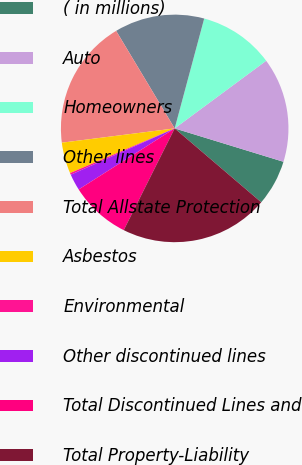<chart> <loc_0><loc_0><loc_500><loc_500><pie_chart><fcel>( in millions)<fcel>Auto<fcel>Homeowners<fcel>Other lines<fcel>Total Allstate Protection<fcel>Asbestos<fcel>Environmental<fcel>Other discontinued lines<fcel>Total Discontinued Lines and<fcel>Total Property-Liability<nl><fcel>6.51%<fcel>14.87%<fcel>10.69%<fcel>12.78%<fcel>18.4%<fcel>4.42%<fcel>0.25%<fcel>2.34%<fcel>8.6%<fcel>21.14%<nl></chart> 